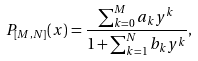<formula> <loc_0><loc_0><loc_500><loc_500>P _ { [ M , N ] } ( x ) = \frac { \sum _ { k = 0 } ^ { M } a _ { k } y ^ { k } } { 1 + \sum _ { k = 1 } ^ { N } b _ { k } y ^ { k } } ,</formula> 